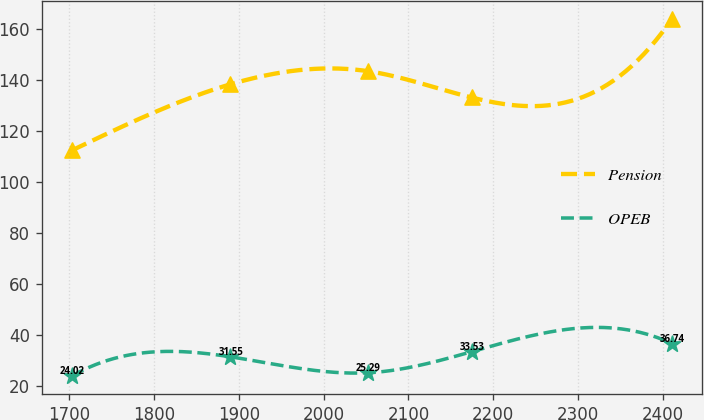Convert chart. <chart><loc_0><loc_0><loc_500><loc_500><line_chart><ecel><fcel>Pension<fcel>OPEB<nl><fcel>1703.16<fcel>112.39<fcel>24.02<nl><fcel>1890.06<fcel>138.29<fcel>31.55<nl><fcel>2052.42<fcel>143.44<fcel>25.29<nl><fcel>2174.34<fcel>133.14<fcel>33.53<nl><fcel>2410.48<fcel>163.86<fcel>36.74<nl></chart> 